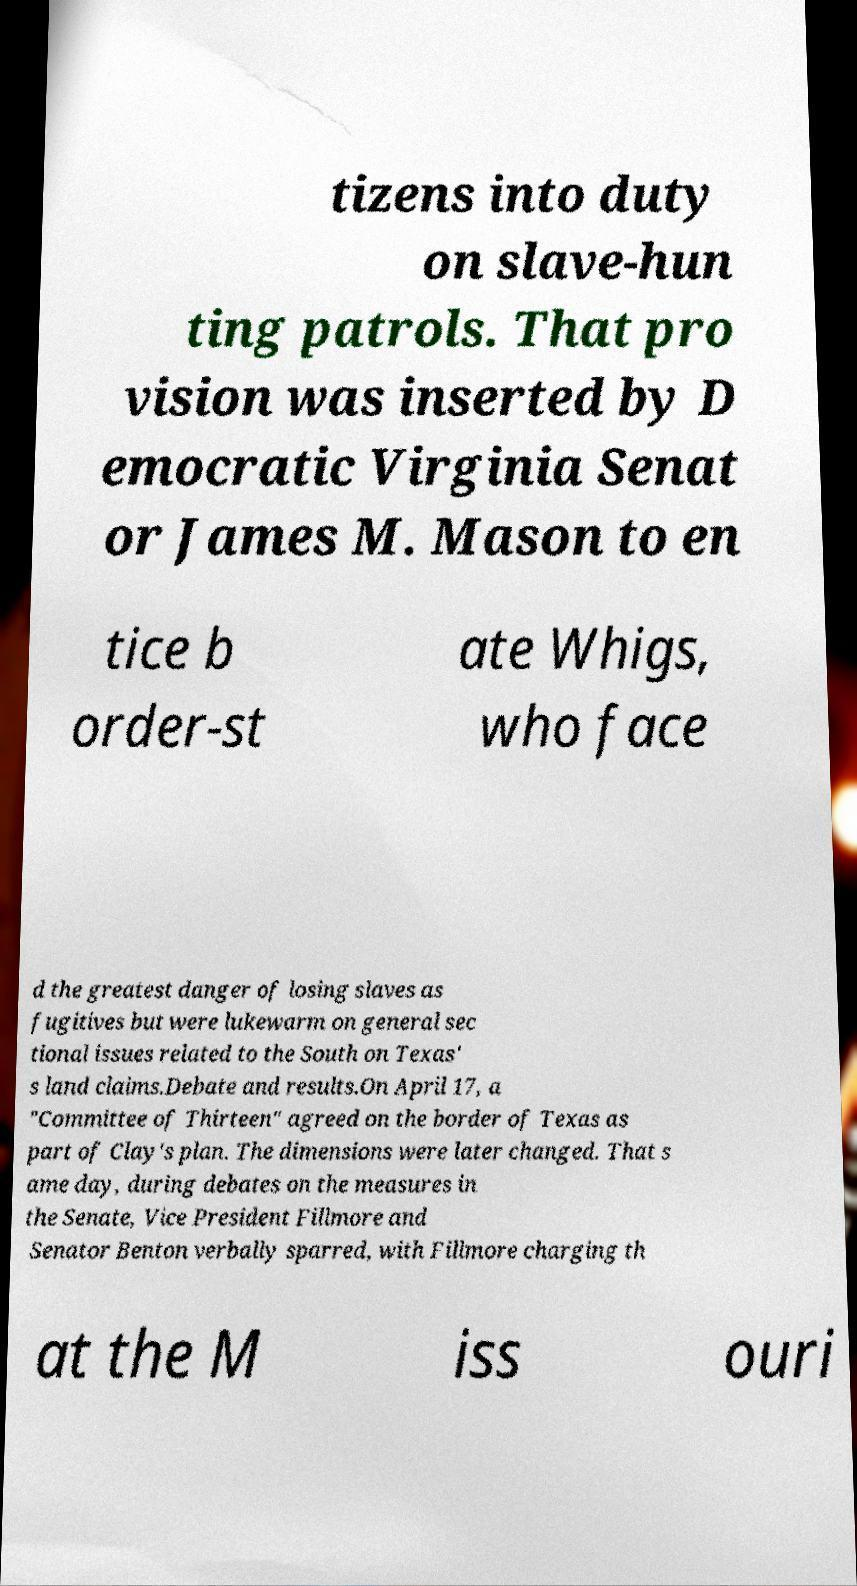Please read and relay the text visible in this image. What does it say? tizens into duty on slave-hun ting patrols. That pro vision was inserted by D emocratic Virginia Senat or James M. Mason to en tice b order-st ate Whigs, who face d the greatest danger of losing slaves as fugitives but were lukewarm on general sec tional issues related to the South on Texas' s land claims.Debate and results.On April 17, a "Committee of Thirteen" agreed on the border of Texas as part of Clay's plan. The dimensions were later changed. That s ame day, during debates on the measures in the Senate, Vice President Fillmore and Senator Benton verbally sparred, with Fillmore charging th at the M iss ouri 